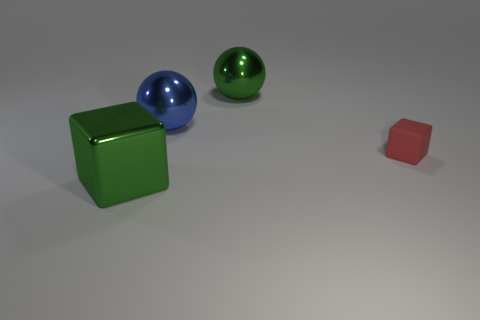There is a cube that is behind the large green object in front of the tiny matte thing; what number of metal objects are in front of it? In the image, there is one metal sphere in front of the large green cube. This is determined by examining the reflective surface and the apparent material of the sphere, which, in combination with its round shape, suggests it is a metal object. 